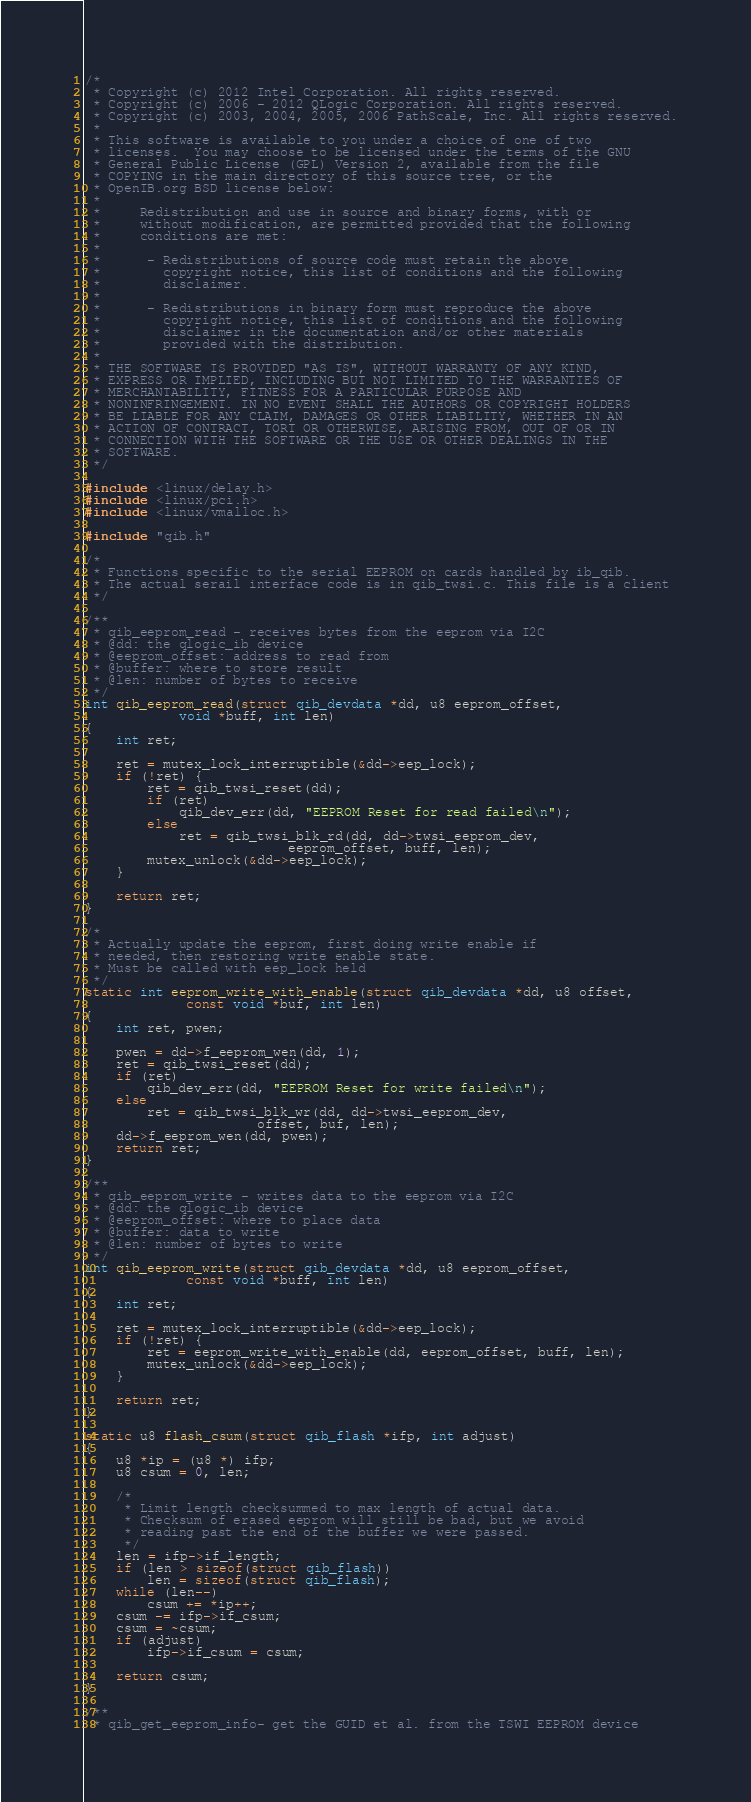Convert code to text. <code><loc_0><loc_0><loc_500><loc_500><_C_>/*
 * Copyright (c) 2012 Intel Corporation. All rights reserved.
 * Copyright (c) 2006 - 2012 QLogic Corporation. All rights reserved.
 * Copyright (c) 2003, 2004, 2005, 2006 PathScale, Inc. All rights reserved.
 *
 * This software is available to you under a choice of one of two
 * licenses.  You may choose to be licensed under the terms of the GNU
 * General Public License (GPL) Version 2, available from the file
 * COPYING in the main directory of this source tree, or the
 * OpenIB.org BSD license below:
 *
 *     Redistribution and use in source and binary forms, with or
 *     without modification, are permitted provided that the following
 *     conditions are met:
 *
 *      - Redistributions of source code must retain the above
 *        copyright notice, this list of conditions and the following
 *        disclaimer.
 *
 *      - Redistributions in binary form must reproduce the above
 *        copyright notice, this list of conditions and the following
 *        disclaimer in the documentation and/or other materials
 *        provided with the distribution.
 *
 * THE SOFTWARE IS PROVIDED "AS IS", WITHOUT WARRANTY OF ANY KIND,
 * EXPRESS OR IMPLIED, INCLUDING BUT NOT LIMITED TO THE WARRANTIES OF
 * MERCHANTABILITY, FITNESS FOR A PARTICULAR PURPOSE AND
 * NONINFRINGEMENT. IN NO EVENT SHALL THE AUTHORS OR COPYRIGHT HOLDERS
 * BE LIABLE FOR ANY CLAIM, DAMAGES OR OTHER LIABILITY, WHETHER IN AN
 * ACTION OF CONTRACT, TORT OR OTHERWISE, ARISING FROM, OUT OF OR IN
 * CONNECTION WITH THE SOFTWARE OR THE USE OR OTHER DEALINGS IN THE
 * SOFTWARE.
 */

#include <linux/delay.h>
#include <linux/pci.h>
#include <linux/vmalloc.h>

#include "qib.h"

/*
 * Functions specific to the serial EEPROM on cards handled by ib_qib.
 * The actual serail interface code is in qib_twsi.c. This file is a client
 */

/**
 * qib_eeprom_read - receives bytes from the eeprom via I2C
 * @dd: the qlogic_ib device
 * @eeprom_offset: address to read from
 * @buffer: where to store result
 * @len: number of bytes to receive
 */
int qib_eeprom_read(struct qib_devdata *dd, u8 eeprom_offset,
		    void *buff, int len)
{
	int ret;

	ret = mutex_lock_interruptible(&dd->eep_lock);
	if (!ret) {
		ret = qib_twsi_reset(dd);
		if (ret)
			qib_dev_err(dd, "EEPROM Reset for read failed\n");
		else
			ret = qib_twsi_blk_rd(dd, dd->twsi_eeprom_dev,
					      eeprom_offset, buff, len);
		mutex_unlock(&dd->eep_lock);
	}

	return ret;
}

/*
 * Actually update the eeprom, first doing write enable if
 * needed, then restoring write enable state.
 * Must be called with eep_lock held
 */
static int eeprom_write_with_enable(struct qib_devdata *dd, u8 offset,
		     const void *buf, int len)
{
	int ret, pwen;

	pwen = dd->f_eeprom_wen(dd, 1);
	ret = qib_twsi_reset(dd);
	if (ret)
		qib_dev_err(dd, "EEPROM Reset for write failed\n");
	else
		ret = qib_twsi_blk_wr(dd, dd->twsi_eeprom_dev,
				      offset, buf, len);
	dd->f_eeprom_wen(dd, pwen);
	return ret;
}

/**
 * qib_eeprom_write - writes data to the eeprom via I2C
 * @dd: the qlogic_ib device
 * @eeprom_offset: where to place data
 * @buffer: data to write
 * @len: number of bytes to write
 */
int qib_eeprom_write(struct qib_devdata *dd, u8 eeprom_offset,
		     const void *buff, int len)
{
	int ret;

	ret = mutex_lock_interruptible(&dd->eep_lock);
	if (!ret) {
		ret = eeprom_write_with_enable(dd, eeprom_offset, buff, len);
		mutex_unlock(&dd->eep_lock);
	}

	return ret;
}

static u8 flash_csum(struct qib_flash *ifp, int adjust)
{
	u8 *ip = (u8 *) ifp;
	u8 csum = 0, len;

	/*
	 * Limit length checksummed to max length of actual data.
	 * Checksum of erased eeprom will still be bad, but we avoid
	 * reading past the end of the buffer we were passed.
	 */
	len = ifp->if_length;
	if (len > sizeof(struct qib_flash))
		len = sizeof(struct qib_flash);
	while (len--)
		csum += *ip++;
	csum -= ifp->if_csum;
	csum = ~csum;
	if (adjust)
		ifp->if_csum = csum;

	return csum;
}

/**
 * qib_get_eeprom_info- get the GUID et al. from the TSWI EEPROM device</code> 